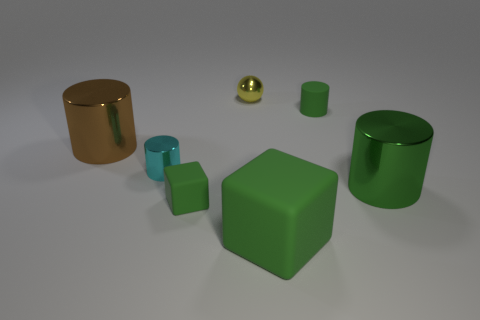Is the tiny rubber cylinder the same color as the big block?
Offer a very short reply. Yes. Are there more large brown metal objects than small purple blocks?
Your response must be concise. Yes. Do the large brown thing in front of the small metal ball and the green shiny object have the same shape?
Offer a terse response. Yes. What number of shiny cylinders are in front of the cyan shiny cylinder and to the left of the yellow ball?
Ensure brevity in your answer.  0. How many tiny yellow metallic objects have the same shape as the big green rubber thing?
Provide a succinct answer. 0. There is a tiny object that is in front of the large metal cylinder to the right of the cyan shiny object; what is its color?
Make the answer very short. Green. There is a cyan object; is it the same shape as the big metal object on the right side of the yellow ball?
Offer a very short reply. Yes. The big green thing that is in front of the tiny green thing that is in front of the big object behind the cyan cylinder is made of what material?
Provide a short and direct response. Rubber. Is there a metal cylinder of the same size as the yellow metal thing?
Your answer should be very brief. Yes. What size is the green cylinder that is the same material as the big brown object?
Provide a succinct answer. Large. 